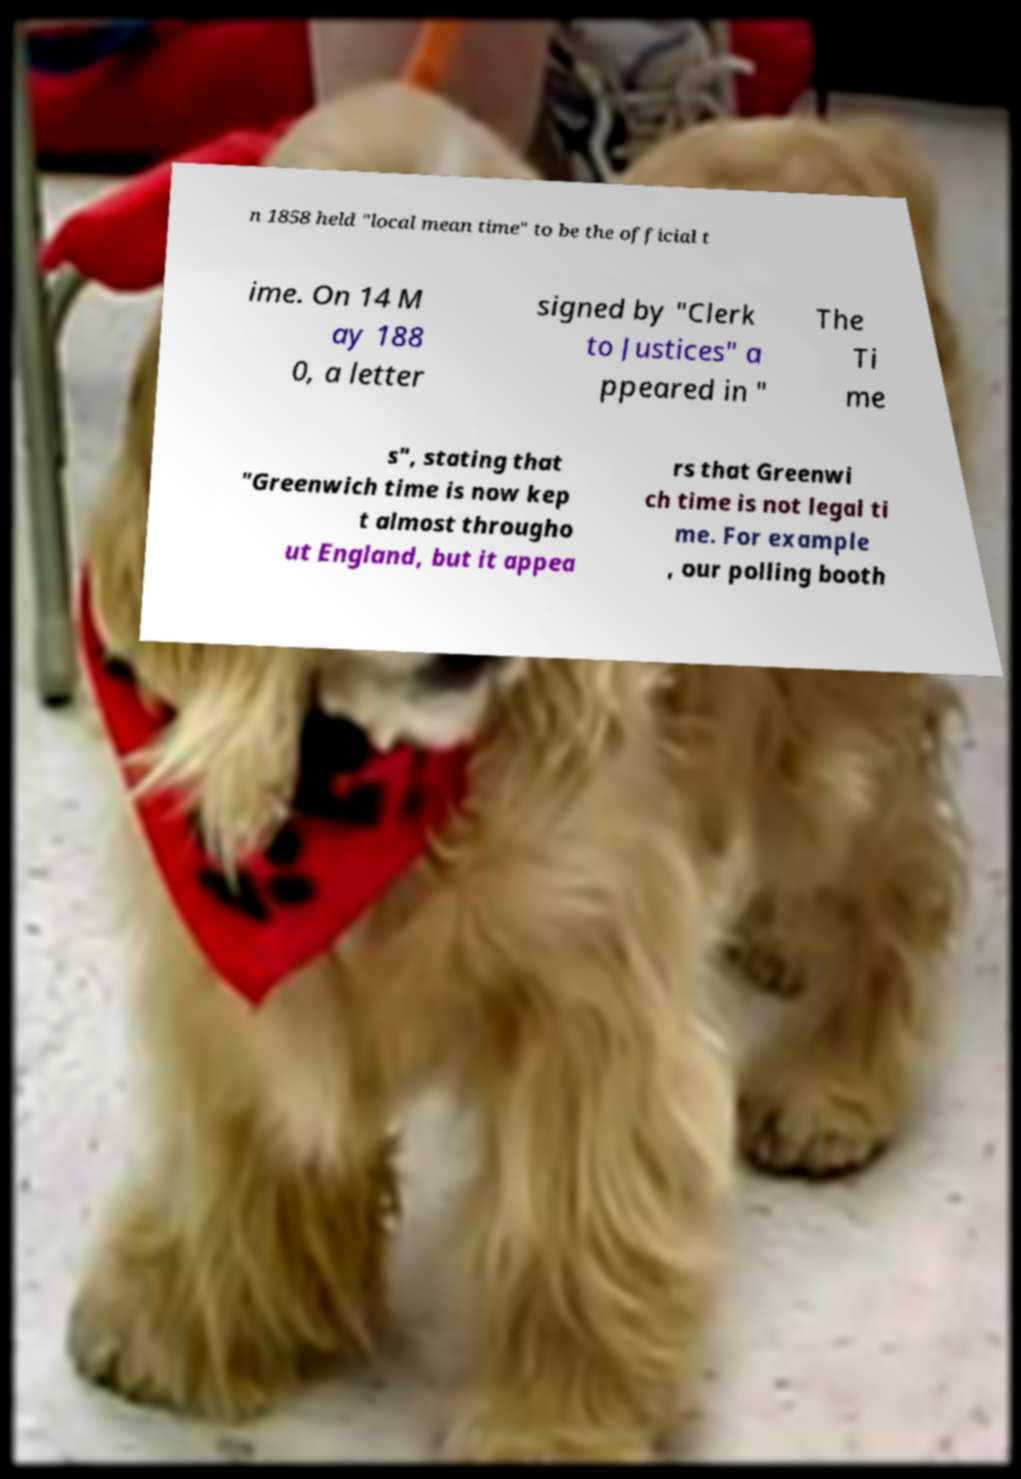I need the written content from this picture converted into text. Can you do that? n 1858 held "local mean time" to be the official t ime. On 14 M ay 188 0, a letter signed by "Clerk to Justices" a ppeared in " The Ti me s", stating that "Greenwich time is now kep t almost througho ut England, but it appea rs that Greenwi ch time is not legal ti me. For example , our polling booth 